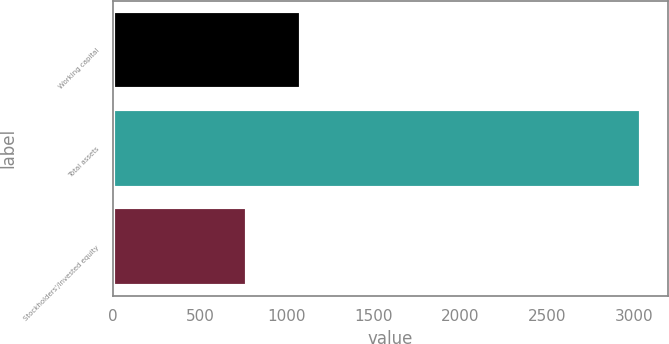<chart> <loc_0><loc_0><loc_500><loc_500><bar_chart><fcel>Working capital<fcel>Total assets<fcel>Stockholders'/Invested equity<nl><fcel>1081<fcel>3041<fcel>769<nl></chart> 